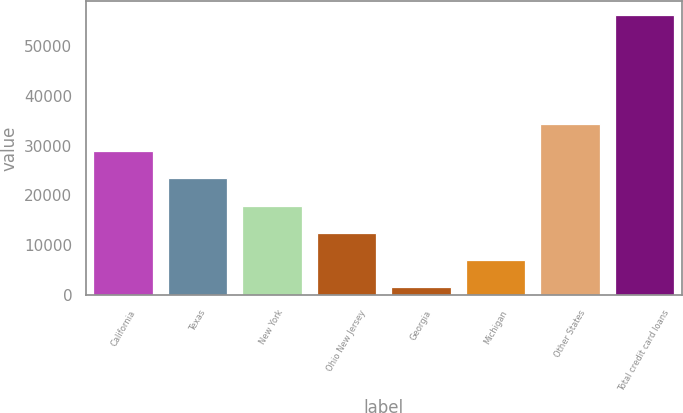<chart> <loc_0><loc_0><loc_500><loc_500><bar_chart><fcel>California<fcel>Texas<fcel>New York<fcel>Ohio New Jersey<fcel>Georgia<fcel>Michigan<fcel>Other States<fcel>Total credit card loans<nl><fcel>28879<fcel>23429.2<fcel>17979.4<fcel>12529.6<fcel>1630<fcel>7079.8<fcel>34328.8<fcel>56128<nl></chart> 